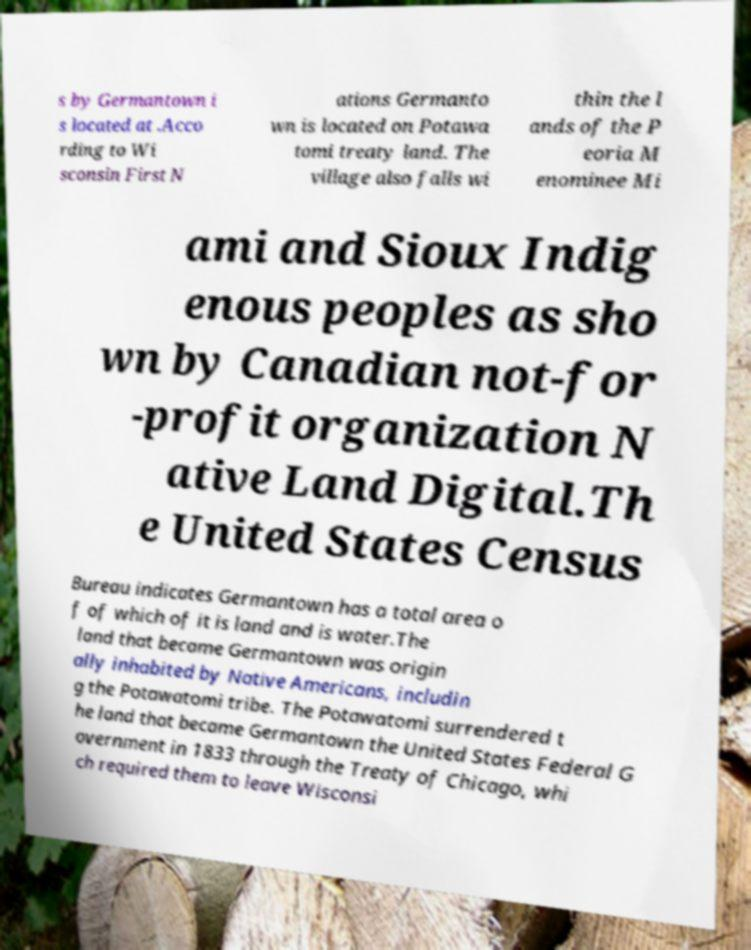Can you accurately transcribe the text from the provided image for me? s by Germantown i s located at .Acco rding to Wi sconsin First N ations Germanto wn is located on Potawa tomi treaty land. The village also falls wi thin the l ands of the P eoria M enominee Mi ami and Sioux Indig enous peoples as sho wn by Canadian not-for -profit organization N ative Land Digital.Th e United States Census Bureau indicates Germantown has a total area o f of which of it is land and is water.The land that became Germantown was origin ally inhabited by Native Americans, includin g the Potawatomi tribe. The Potawatomi surrendered t he land that became Germantown the United States Federal G overnment in 1833 through the Treaty of Chicago, whi ch required them to leave Wisconsi 